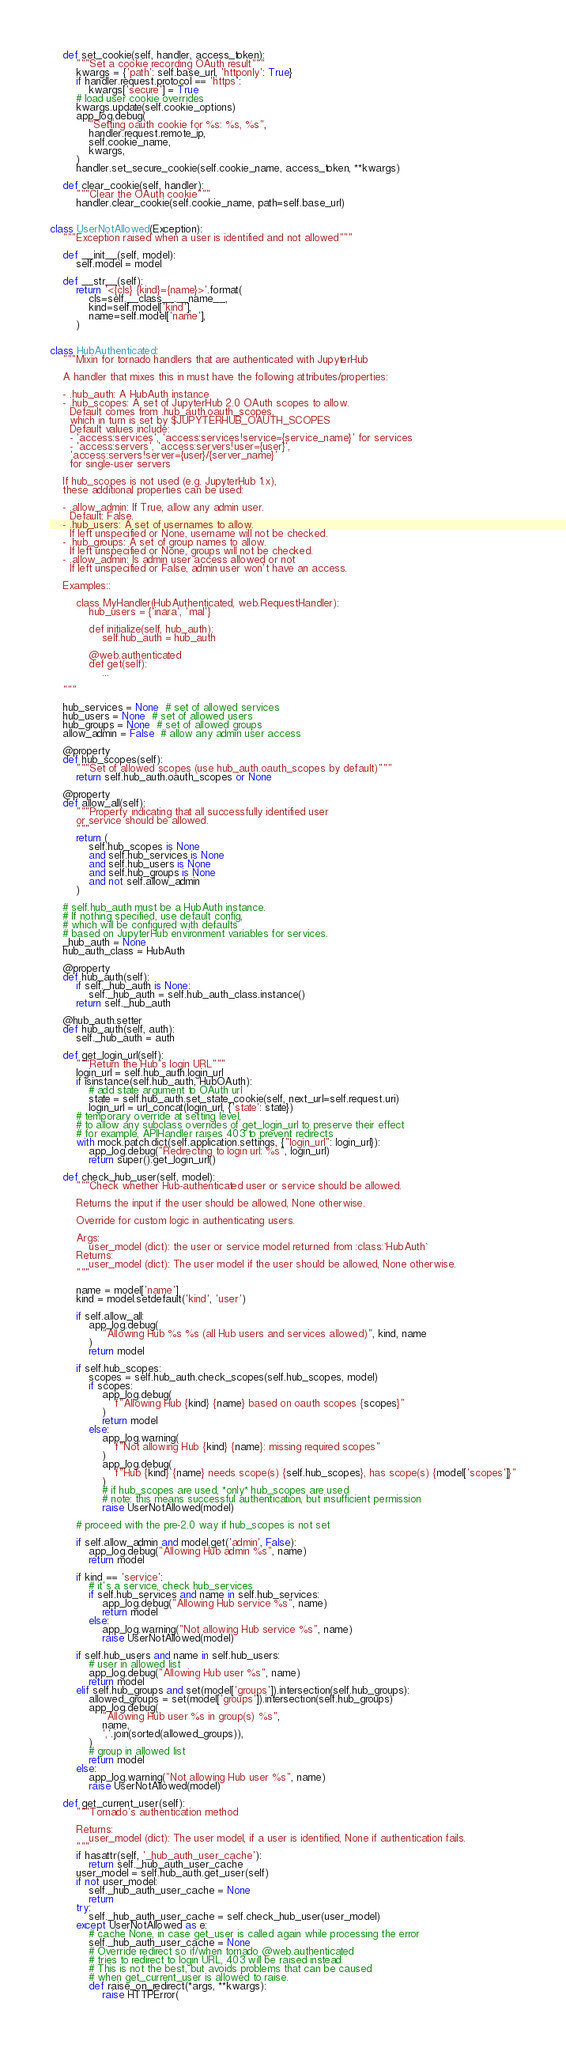Convert code to text. <code><loc_0><loc_0><loc_500><loc_500><_Python_>
    def set_cookie(self, handler, access_token):
        """Set a cookie recording OAuth result"""
        kwargs = {'path': self.base_url, 'httponly': True}
        if handler.request.protocol == 'https':
            kwargs['secure'] = True
        # load user cookie overrides
        kwargs.update(self.cookie_options)
        app_log.debug(
            "Setting oauth cookie for %s: %s, %s",
            handler.request.remote_ip,
            self.cookie_name,
            kwargs,
        )
        handler.set_secure_cookie(self.cookie_name, access_token, **kwargs)

    def clear_cookie(self, handler):
        """Clear the OAuth cookie"""
        handler.clear_cookie(self.cookie_name, path=self.base_url)


class UserNotAllowed(Exception):
    """Exception raised when a user is identified and not allowed"""

    def __init__(self, model):
        self.model = model

    def __str__(self):
        return '<{cls} {kind}={name}>'.format(
            cls=self.__class__.__name__,
            kind=self.model['kind'],
            name=self.model['name'],
        )


class HubAuthenticated:
    """Mixin for tornado handlers that are authenticated with JupyterHub

    A handler that mixes this in must have the following attributes/properties:

    - .hub_auth: A HubAuth instance
    - .hub_scopes: A set of JupyterHub 2.0 OAuth scopes to allow.
      Default comes from .hub_auth.oauth_scopes,
      which in turn is set by $JUPYTERHUB_OAUTH_SCOPES
      Default values include:
      - 'access:services', 'access:services!service={service_name}' for services
      - 'access:servers', 'access:servers!user={user}',
      'access:servers!server={user}/{server_name}'
      for single-user servers

    If hub_scopes is not used (e.g. JupyterHub 1.x),
    these additional properties can be used:

    - .allow_admin: If True, allow any admin user.
      Default: False.
    - .hub_users: A set of usernames to allow.
      If left unspecified or None, username will not be checked.
    - .hub_groups: A set of group names to allow.
      If left unspecified or None, groups will not be checked.
    - .allow_admin: Is admin user access allowed or not
      If left unspecified or False, admin user won't have an access.

    Examples::

        class MyHandler(HubAuthenticated, web.RequestHandler):
            hub_users = {'inara', 'mal'}

            def initialize(self, hub_auth):
                self.hub_auth = hub_auth

            @web.authenticated
            def get(self):
                ...

    """

    hub_services = None  # set of allowed services
    hub_users = None  # set of allowed users
    hub_groups = None  # set of allowed groups
    allow_admin = False  # allow any admin user access

    @property
    def hub_scopes(self):
        """Set of allowed scopes (use hub_auth.oauth_scopes by default)"""
        return self.hub_auth.oauth_scopes or None

    @property
    def allow_all(self):
        """Property indicating that all successfully identified user
        or service should be allowed.
        """
        return (
            self.hub_scopes is None
            and self.hub_services is None
            and self.hub_users is None
            and self.hub_groups is None
            and not self.allow_admin
        )

    # self.hub_auth must be a HubAuth instance.
    # If nothing specified, use default config,
    # which will be configured with defaults
    # based on JupyterHub environment variables for services.
    _hub_auth = None
    hub_auth_class = HubAuth

    @property
    def hub_auth(self):
        if self._hub_auth is None:
            self._hub_auth = self.hub_auth_class.instance()
        return self._hub_auth

    @hub_auth.setter
    def hub_auth(self, auth):
        self._hub_auth = auth

    def get_login_url(self):
        """Return the Hub's login URL"""
        login_url = self.hub_auth.login_url
        if isinstance(self.hub_auth, HubOAuth):
            # add state argument to OAuth url
            state = self.hub_auth.set_state_cookie(self, next_url=self.request.uri)
            login_url = url_concat(login_url, {'state': state})
        # temporary override at setting level,
        # to allow any subclass overrides of get_login_url to preserve their effect
        # for example, APIHandler raises 403 to prevent redirects
        with mock.patch.dict(self.application.settings, {"login_url": login_url}):
            app_log.debug("Redirecting to login url: %s", login_url)
            return super().get_login_url()

    def check_hub_user(self, model):
        """Check whether Hub-authenticated user or service should be allowed.

        Returns the input if the user should be allowed, None otherwise.

        Override for custom logic in authenticating users.

        Args:
            user_model (dict): the user or service model returned from :class:`HubAuth`
        Returns:
            user_model (dict): The user model if the user should be allowed, None otherwise.
        """

        name = model['name']
        kind = model.setdefault('kind', 'user')

        if self.allow_all:
            app_log.debug(
                "Allowing Hub %s %s (all Hub users and services allowed)", kind, name
            )
            return model

        if self.hub_scopes:
            scopes = self.hub_auth.check_scopes(self.hub_scopes, model)
            if scopes:
                app_log.debug(
                    f"Allowing Hub {kind} {name} based on oauth scopes {scopes}"
                )
                return model
            else:
                app_log.warning(
                    f"Not allowing Hub {kind} {name}: missing required scopes"
                )
                app_log.debug(
                    f"Hub {kind} {name} needs scope(s) {self.hub_scopes}, has scope(s) {model['scopes']}"
                )
                # if hub_scopes are used, *only* hub_scopes are used
                # note: this means successful authentication, but insufficient permission
                raise UserNotAllowed(model)

        # proceed with the pre-2.0 way if hub_scopes is not set

        if self.allow_admin and model.get('admin', False):
            app_log.debug("Allowing Hub admin %s", name)
            return model

        if kind == 'service':
            # it's a service, check hub_services
            if self.hub_services and name in self.hub_services:
                app_log.debug("Allowing Hub service %s", name)
                return model
            else:
                app_log.warning("Not allowing Hub service %s", name)
                raise UserNotAllowed(model)

        if self.hub_users and name in self.hub_users:
            # user in allowed list
            app_log.debug("Allowing Hub user %s", name)
            return model
        elif self.hub_groups and set(model['groups']).intersection(self.hub_groups):
            allowed_groups = set(model['groups']).intersection(self.hub_groups)
            app_log.debug(
                "Allowing Hub user %s in group(s) %s",
                name,
                ','.join(sorted(allowed_groups)),
            )
            # group in allowed list
            return model
        else:
            app_log.warning("Not allowing Hub user %s", name)
            raise UserNotAllowed(model)

    def get_current_user(self):
        """Tornado's authentication method

        Returns:
            user_model (dict): The user model, if a user is identified, None if authentication fails.
        """
        if hasattr(self, '_hub_auth_user_cache'):
            return self._hub_auth_user_cache
        user_model = self.hub_auth.get_user(self)
        if not user_model:
            self._hub_auth_user_cache = None
            return
        try:
            self._hub_auth_user_cache = self.check_hub_user(user_model)
        except UserNotAllowed as e:
            # cache None, in case get_user is called again while processing the error
            self._hub_auth_user_cache = None
            # Override redirect so if/when tornado @web.authenticated
            # tries to redirect to login URL, 403 will be raised instead.
            # This is not the best, but avoids problems that can be caused
            # when get_current_user is allowed to raise.
            def raise_on_redirect(*args, **kwargs):
                raise HTTPError(</code> 